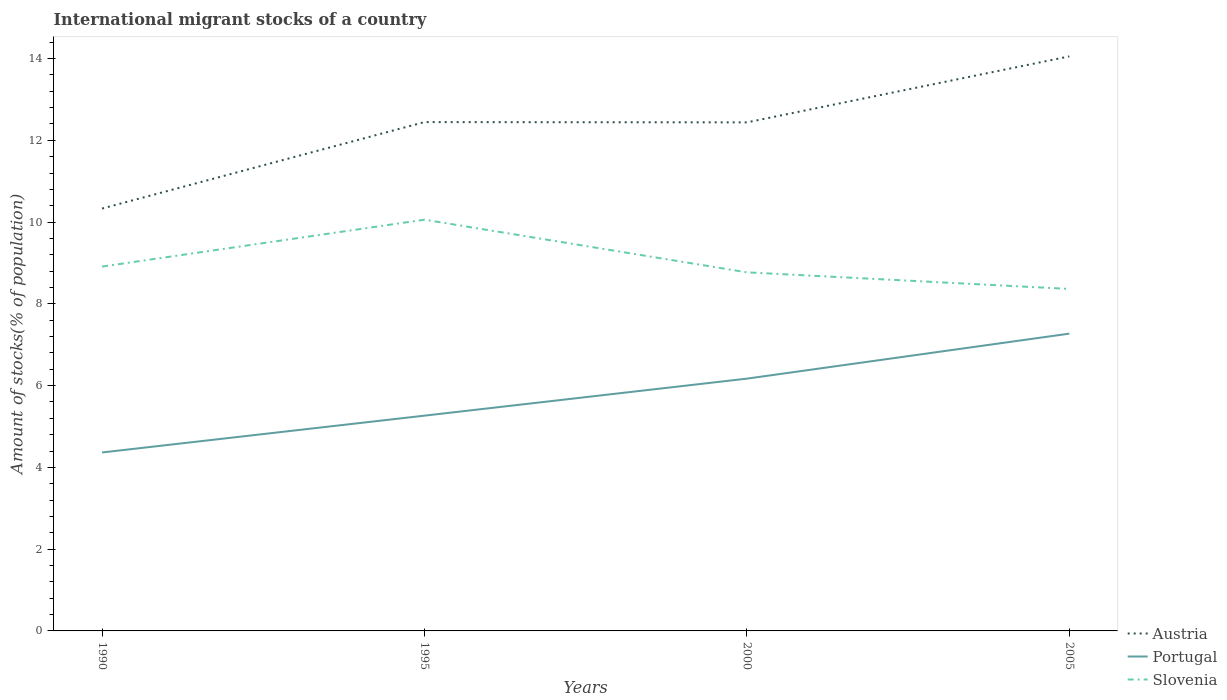How many different coloured lines are there?
Your answer should be very brief. 3. Is the number of lines equal to the number of legend labels?
Make the answer very short. Yes. Across all years, what is the maximum amount of stocks in in Portugal?
Offer a very short reply. 4.37. In which year was the amount of stocks in in Portugal maximum?
Make the answer very short. 1990. What is the total amount of stocks in in Austria in the graph?
Offer a terse response. -1.61. What is the difference between the highest and the second highest amount of stocks in in Portugal?
Your answer should be very brief. 2.91. How many years are there in the graph?
Make the answer very short. 4. Does the graph contain any zero values?
Your answer should be very brief. No. Does the graph contain grids?
Provide a succinct answer. No. Where does the legend appear in the graph?
Your answer should be very brief. Bottom right. How are the legend labels stacked?
Provide a short and direct response. Vertical. What is the title of the graph?
Offer a very short reply. International migrant stocks of a country. What is the label or title of the Y-axis?
Provide a short and direct response. Amount of stocks(% of population). What is the Amount of stocks(% of population) in Austria in 1990?
Keep it short and to the point. 10.33. What is the Amount of stocks(% of population) in Portugal in 1990?
Ensure brevity in your answer.  4.37. What is the Amount of stocks(% of population) of Slovenia in 1990?
Offer a very short reply. 8.91. What is the Amount of stocks(% of population) of Austria in 1995?
Provide a short and direct response. 12.45. What is the Amount of stocks(% of population) of Portugal in 1995?
Make the answer very short. 5.27. What is the Amount of stocks(% of population) in Slovenia in 1995?
Your answer should be compact. 10.06. What is the Amount of stocks(% of population) of Austria in 2000?
Your answer should be compact. 12.44. What is the Amount of stocks(% of population) of Portugal in 2000?
Provide a short and direct response. 6.17. What is the Amount of stocks(% of population) of Slovenia in 2000?
Your answer should be compact. 8.77. What is the Amount of stocks(% of population) of Austria in 2005?
Provide a succinct answer. 14.05. What is the Amount of stocks(% of population) in Portugal in 2005?
Provide a succinct answer. 7.27. What is the Amount of stocks(% of population) of Slovenia in 2005?
Make the answer very short. 8.36. Across all years, what is the maximum Amount of stocks(% of population) in Austria?
Give a very brief answer. 14.05. Across all years, what is the maximum Amount of stocks(% of population) of Portugal?
Ensure brevity in your answer.  7.27. Across all years, what is the maximum Amount of stocks(% of population) in Slovenia?
Your response must be concise. 10.06. Across all years, what is the minimum Amount of stocks(% of population) of Austria?
Offer a terse response. 10.33. Across all years, what is the minimum Amount of stocks(% of population) in Portugal?
Your answer should be compact. 4.37. Across all years, what is the minimum Amount of stocks(% of population) of Slovenia?
Offer a terse response. 8.36. What is the total Amount of stocks(% of population) of Austria in the graph?
Ensure brevity in your answer.  49.27. What is the total Amount of stocks(% of population) of Portugal in the graph?
Your response must be concise. 23.07. What is the total Amount of stocks(% of population) in Slovenia in the graph?
Your answer should be compact. 36.11. What is the difference between the Amount of stocks(% of population) of Austria in 1990 and that in 1995?
Give a very brief answer. -2.11. What is the difference between the Amount of stocks(% of population) of Portugal in 1990 and that in 1995?
Provide a short and direct response. -0.9. What is the difference between the Amount of stocks(% of population) of Slovenia in 1990 and that in 1995?
Give a very brief answer. -1.15. What is the difference between the Amount of stocks(% of population) of Austria in 1990 and that in 2000?
Keep it short and to the point. -2.11. What is the difference between the Amount of stocks(% of population) in Portugal in 1990 and that in 2000?
Ensure brevity in your answer.  -1.81. What is the difference between the Amount of stocks(% of population) of Slovenia in 1990 and that in 2000?
Provide a succinct answer. 0.14. What is the difference between the Amount of stocks(% of population) in Austria in 1990 and that in 2005?
Make the answer very short. -3.72. What is the difference between the Amount of stocks(% of population) of Portugal in 1990 and that in 2005?
Your answer should be very brief. -2.91. What is the difference between the Amount of stocks(% of population) of Slovenia in 1990 and that in 2005?
Ensure brevity in your answer.  0.55. What is the difference between the Amount of stocks(% of population) in Austria in 1995 and that in 2000?
Give a very brief answer. 0.01. What is the difference between the Amount of stocks(% of population) in Portugal in 1995 and that in 2000?
Your response must be concise. -0.91. What is the difference between the Amount of stocks(% of population) of Slovenia in 1995 and that in 2000?
Make the answer very short. 1.29. What is the difference between the Amount of stocks(% of population) of Austria in 1995 and that in 2005?
Give a very brief answer. -1.61. What is the difference between the Amount of stocks(% of population) of Portugal in 1995 and that in 2005?
Offer a terse response. -2.01. What is the difference between the Amount of stocks(% of population) of Slovenia in 1995 and that in 2005?
Keep it short and to the point. 1.69. What is the difference between the Amount of stocks(% of population) in Austria in 2000 and that in 2005?
Your answer should be very brief. -1.61. What is the difference between the Amount of stocks(% of population) in Portugal in 2000 and that in 2005?
Give a very brief answer. -1.1. What is the difference between the Amount of stocks(% of population) in Slovenia in 2000 and that in 2005?
Offer a very short reply. 0.41. What is the difference between the Amount of stocks(% of population) of Austria in 1990 and the Amount of stocks(% of population) of Portugal in 1995?
Keep it short and to the point. 5.07. What is the difference between the Amount of stocks(% of population) in Austria in 1990 and the Amount of stocks(% of population) in Slovenia in 1995?
Provide a short and direct response. 0.27. What is the difference between the Amount of stocks(% of population) of Portugal in 1990 and the Amount of stocks(% of population) of Slovenia in 1995?
Offer a terse response. -5.69. What is the difference between the Amount of stocks(% of population) of Austria in 1990 and the Amount of stocks(% of population) of Portugal in 2000?
Provide a short and direct response. 4.16. What is the difference between the Amount of stocks(% of population) of Austria in 1990 and the Amount of stocks(% of population) of Slovenia in 2000?
Keep it short and to the point. 1.56. What is the difference between the Amount of stocks(% of population) in Portugal in 1990 and the Amount of stocks(% of population) in Slovenia in 2000?
Ensure brevity in your answer.  -4.41. What is the difference between the Amount of stocks(% of population) in Austria in 1990 and the Amount of stocks(% of population) in Portugal in 2005?
Keep it short and to the point. 3.06. What is the difference between the Amount of stocks(% of population) of Austria in 1990 and the Amount of stocks(% of population) of Slovenia in 2005?
Provide a short and direct response. 1.97. What is the difference between the Amount of stocks(% of population) in Portugal in 1990 and the Amount of stocks(% of population) in Slovenia in 2005?
Give a very brief answer. -4. What is the difference between the Amount of stocks(% of population) of Austria in 1995 and the Amount of stocks(% of population) of Portugal in 2000?
Make the answer very short. 6.28. What is the difference between the Amount of stocks(% of population) in Austria in 1995 and the Amount of stocks(% of population) in Slovenia in 2000?
Your answer should be very brief. 3.68. What is the difference between the Amount of stocks(% of population) of Portugal in 1995 and the Amount of stocks(% of population) of Slovenia in 2000?
Make the answer very short. -3.5. What is the difference between the Amount of stocks(% of population) in Austria in 1995 and the Amount of stocks(% of population) in Portugal in 2005?
Keep it short and to the point. 5.17. What is the difference between the Amount of stocks(% of population) in Austria in 1995 and the Amount of stocks(% of population) in Slovenia in 2005?
Provide a short and direct response. 4.08. What is the difference between the Amount of stocks(% of population) in Portugal in 1995 and the Amount of stocks(% of population) in Slovenia in 2005?
Provide a short and direct response. -3.1. What is the difference between the Amount of stocks(% of population) in Austria in 2000 and the Amount of stocks(% of population) in Portugal in 2005?
Offer a very short reply. 5.17. What is the difference between the Amount of stocks(% of population) in Austria in 2000 and the Amount of stocks(% of population) in Slovenia in 2005?
Give a very brief answer. 4.07. What is the difference between the Amount of stocks(% of population) of Portugal in 2000 and the Amount of stocks(% of population) of Slovenia in 2005?
Your answer should be compact. -2.19. What is the average Amount of stocks(% of population) in Austria per year?
Give a very brief answer. 12.32. What is the average Amount of stocks(% of population) of Portugal per year?
Give a very brief answer. 5.77. What is the average Amount of stocks(% of population) in Slovenia per year?
Your answer should be compact. 9.03. In the year 1990, what is the difference between the Amount of stocks(% of population) of Austria and Amount of stocks(% of population) of Portugal?
Make the answer very short. 5.97. In the year 1990, what is the difference between the Amount of stocks(% of population) in Austria and Amount of stocks(% of population) in Slovenia?
Give a very brief answer. 1.42. In the year 1990, what is the difference between the Amount of stocks(% of population) in Portugal and Amount of stocks(% of population) in Slovenia?
Keep it short and to the point. -4.55. In the year 1995, what is the difference between the Amount of stocks(% of population) in Austria and Amount of stocks(% of population) in Portugal?
Offer a terse response. 7.18. In the year 1995, what is the difference between the Amount of stocks(% of population) in Austria and Amount of stocks(% of population) in Slovenia?
Offer a terse response. 2.39. In the year 1995, what is the difference between the Amount of stocks(% of population) of Portugal and Amount of stocks(% of population) of Slovenia?
Give a very brief answer. -4.79. In the year 2000, what is the difference between the Amount of stocks(% of population) of Austria and Amount of stocks(% of population) of Portugal?
Your answer should be very brief. 6.27. In the year 2000, what is the difference between the Amount of stocks(% of population) in Austria and Amount of stocks(% of population) in Slovenia?
Provide a succinct answer. 3.67. In the year 2000, what is the difference between the Amount of stocks(% of population) in Portugal and Amount of stocks(% of population) in Slovenia?
Your answer should be very brief. -2.6. In the year 2005, what is the difference between the Amount of stocks(% of population) in Austria and Amount of stocks(% of population) in Portugal?
Provide a short and direct response. 6.78. In the year 2005, what is the difference between the Amount of stocks(% of population) in Austria and Amount of stocks(% of population) in Slovenia?
Ensure brevity in your answer.  5.69. In the year 2005, what is the difference between the Amount of stocks(% of population) in Portugal and Amount of stocks(% of population) in Slovenia?
Provide a short and direct response. -1.09. What is the ratio of the Amount of stocks(% of population) in Austria in 1990 to that in 1995?
Make the answer very short. 0.83. What is the ratio of the Amount of stocks(% of population) of Portugal in 1990 to that in 1995?
Provide a short and direct response. 0.83. What is the ratio of the Amount of stocks(% of population) in Slovenia in 1990 to that in 1995?
Ensure brevity in your answer.  0.89. What is the ratio of the Amount of stocks(% of population) in Austria in 1990 to that in 2000?
Give a very brief answer. 0.83. What is the ratio of the Amount of stocks(% of population) of Portugal in 1990 to that in 2000?
Your answer should be compact. 0.71. What is the ratio of the Amount of stocks(% of population) of Slovenia in 1990 to that in 2000?
Keep it short and to the point. 1.02. What is the ratio of the Amount of stocks(% of population) of Austria in 1990 to that in 2005?
Make the answer very short. 0.74. What is the ratio of the Amount of stocks(% of population) of Portugal in 1990 to that in 2005?
Provide a succinct answer. 0.6. What is the ratio of the Amount of stocks(% of population) of Slovenia in 1990 to that in 2005?
Your answer should be compact. 1.07. What is the ratio of the Amount of stocks(% of population) in Austria in 1995 to that in 2000?
Provide a short and direct response. 1. What is the ratio of the Amount of stocks(% of population) in Portugal in 1995 to that in 2000?
Your response must be concise. 0.85. What is the ratio of the Amount of stocks(% of population) in Slovenia in 1995 to that in 2000?
Ensure brevity in your answer.  1.15. What is the ratio of the Amount of stocks(% of population) in Austria in 1995 to that in 2005?
Provide a short and direct response. 0.89. What is the ratio of the Amount of stocks(% of population) in Portugal in 1995 to that in 2005?
Make the answer very short. 0.72. What is the ratio of the Amount of stocks(% of population) in Slovenia in 1995 to that in 2005?
Provide a short and direct response. 1.2. What is the ratio of the Amount of stocks(% of population) in Austria in 2000 to that in 2005?
Offer a very short reply. 0.89. What is the ratio of the Amount of stocks(% of population) of Portugal in 2000 to that in 2005?
Make the answer very short. 0.85. What is the ratio of the Amount of stocks(% of population) in Slovenia in 2000 to that in 2005?
Your answer should be very brief. 1.05. What is the difference between the highest and the second highest Amount of stocks(% of population) of Austria?
Your answer should be compact. 1.61. What is the difference between the highest and the second highest Amount of stocks(% of population) in Portugal?
Your answer should be compact. 1.1. What is the difference between the highest and the second highest Amount of stocks(% of population) in Slovenia?
Your answer should be compact. 1.15. What is the difference between the highest and the lowest Amount of stocks(% of population) of Austria?
Ensure brevity in your answer.  3.72. What is the difference between the highest and the lowest Amount of stocks(% of population) in Portugal?
Give a very brief answer. 2.91. What is the difference between the highest and the lowest Amount of stocks(% of population) in Slovenia?
Provide a succinct answer. 1.69. 